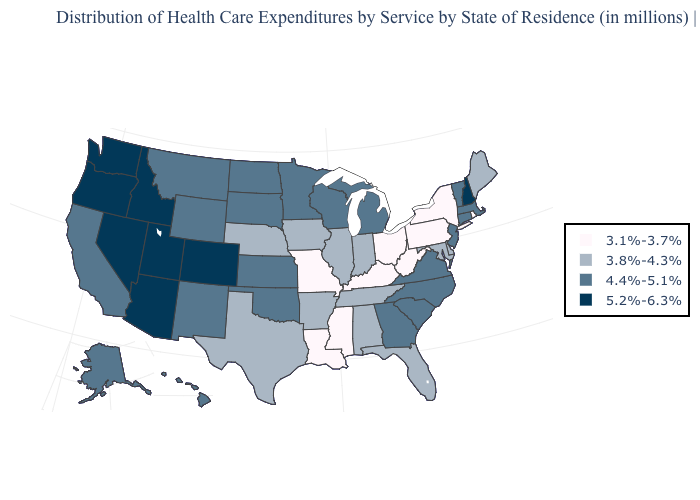What is the value of Connecticut?
Short answer required. 4.4%-5.1%. Name the states that have a value in the range 3.8%-4.3%?
Give a very brief answer. Alabama, Arkansas, Delaware, Florida, Illinois, Indiana, Iowa, Maine, Maryland, Nebraska, Tennessee, Texas. Name the states that have a value in the range 5.2%-6.3%?
Short answer required. Arizona, Colorado, Idaho, Nevada, New Hampshire, Oregon, Utah, Washington. What is the lowest value in the West?
Give a very brief answer. 4.4%-5.1%. Name the states that have a value in the range 5.2%-6.3%?
Answer briefly. Arizona, Colorado, Idaho, Nevada, New Hampshire, Oregon, Utah, Washington. What is the value of Nevada?
Write a very short answer. 5.2%-6.3%. Does the map have missing data?
Answer briefly. No. Among the states that border Louisiana , does Mississippi have the lowest value?
Quick response, please. Yes. Does Louisiana have the lowest value in the USA?
Short answer required. Yes. Among the states that border Wyoming , which have the lowest value?
Short answer required. Nebraska. Among the states that border Delaware , does Pennsylvania have the lowest value?
Answer briefly. Yes. Does Florida have the same value as New York?
Quick response, please. No. Does Alaska have the same value as Oregon?
Be succinct. No. Which states have the lowest value in the MidWest?
Concise answer only. Missouri, Ohio. Which states have the lowest value in the USA?
Be succinct. Kentucky, Louisiana, Mississippi, Missouri, New York, Ohio, Pennsylvania, Rhode Island, West Virginia. 